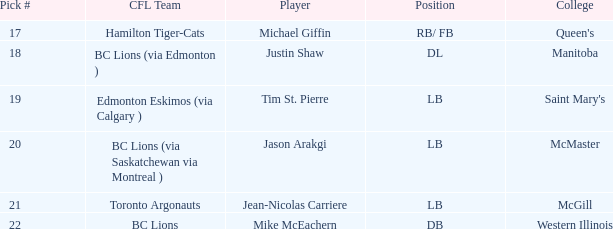What was the count of pick numbers owned by michael giffin? 1.0. 